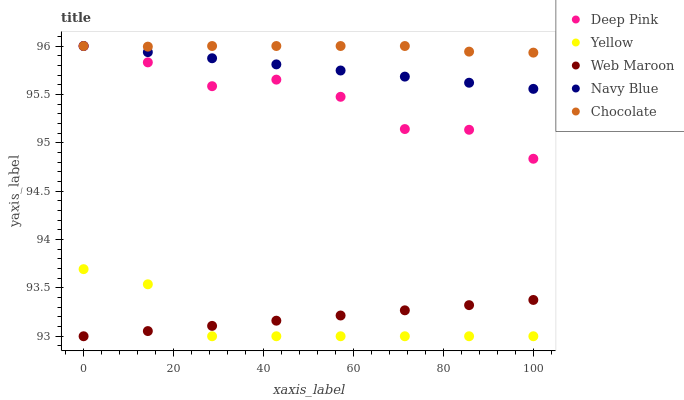Does Yellow have the minimum area under the curve?
Answer yes or no. Yes. Does Chocolate have the maximum area under the curve?
Answer yes or no. Yes. Does Deep Pink have the minimum area under the curve?
Answer yes or no. No. Does Deep Pink have the maximum area under the curve?
Answer yes or no. No. Is Navy Blue the smoothest?
Answer yes or no. Yes. Is Deep Pink the roughest?
Answer yes or no. Yes. Is Web Maroon the smoothest?
Answer yes or no. No. Is Web Maroon the roughest?
Answer yes or no. No. Does Web Maroon have the lowest value?
Answer yes or no. Yes. Does Deep Pink have the lowest value?
Answer yes or no. No. Does Chocolate have the highest value?
Answer yes or no. Yes. Does Web Maroon have the highest value?
Answer yes or no. No. Is Yellow less than Chocolate?
Answer yes or no. Yes. Is Chocolate greater than Yellow?
Answer yes or no. Yes. Does Web Maroon intersect Yellow?
Answer yes or no. Yes. Is Web Maroon less than Yellow?
Answer yes or no. No. Is Web Maroon greater than Yellow?
Answer yes or no. No. Does Yellow intersect Chocolate?
Answer yes or no. No. 